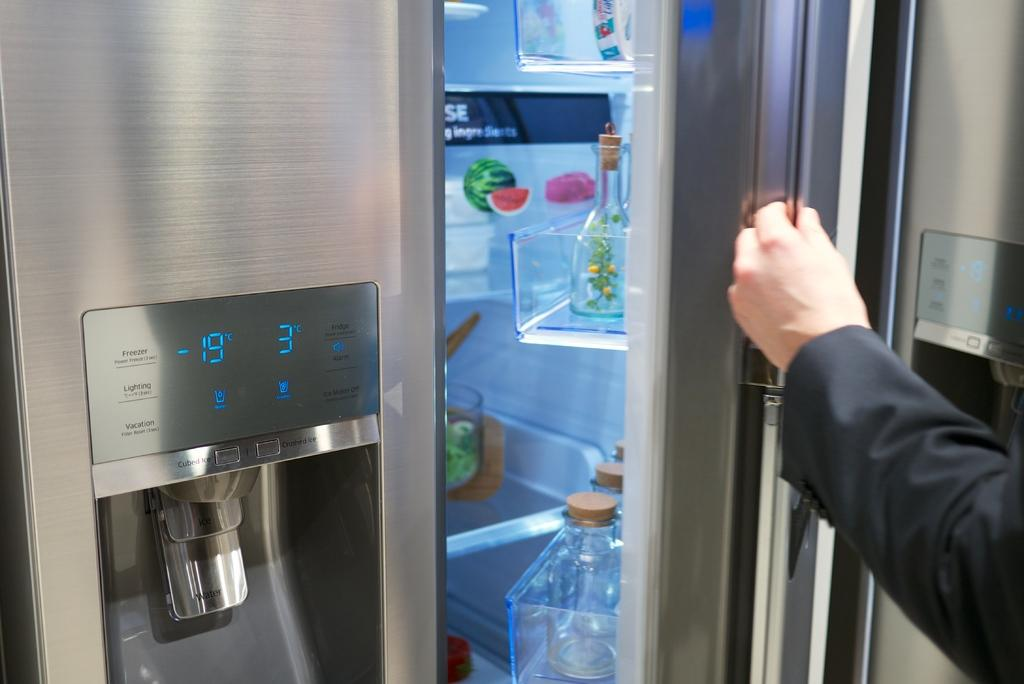Provide a one-sentence caption for the provided image. A stainless steel refrigerator has a digital displaying  -19. 